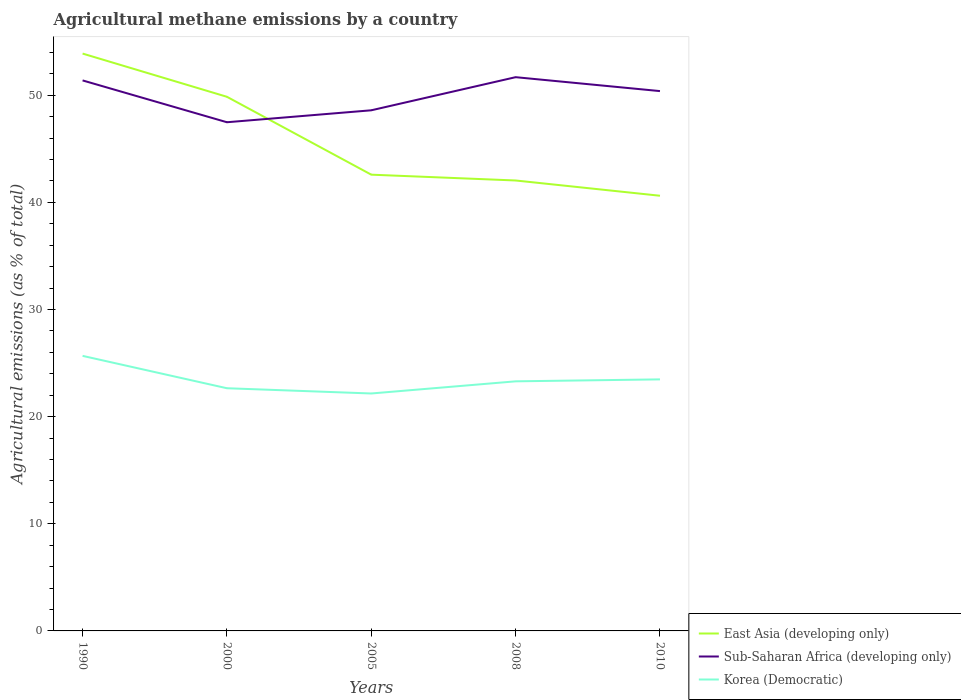How many different coloured lines are there?
Provide a short and direct response. 3. Is the number of lines equal to the number of legend labels?
Keep it short and to the point. Yes. Across all years, what is the maximum amount of agricultural methane emitted in East Asia (developing only)?
Your answer should be compact. 40.62. In which year was the amount of agricultural methane emitted in Sub-Saharan Africa (developing only) maximum?
Give a very brief answer. 2000. What is the total amount of agricultural methane emitted in Korea (Democratic) in the graph?
Your response must be concise. 2.19. What is the difference between the highest and the second highest amount of agricultural methane emitted in Korea (Democratic)?
Provide a succinct answer. 3.51. What is the difference between the highest and the lowest amount of agricultural methane emitted in Korea (Democratic)?
Keep it short and to the point. 2. Is the amount of agricultural methane emitted in Sub-Saharan Africa (developing only) strictly greater than the amount of agricultural methane emitted in East Asia (developing only) over the years?
Give a very brief answer. No. How many years are there in the graph?
Provide a short and direct response. 5. Does the graph contain any zero values?
Your response must be concise. No. Does the graph contain grids?
Offer a very short reply. No. How many legend labels are there?
Your response must be concise. 3. What is the title of the graph?
Your response must be concise. Agricultural methane emissions by a country. Does "Tunisia" appear as one of the legend labels in the graph?
Provide a succinct answer. No. What is the label or title of the X-axis?
Your answer should be very brief. Years. What is the label or title of the Y-axis?
Offer a terse response. Agricultural emissions (as % of total). What is the Agricultural emissions (as % of total) in East Asia (developing only) in 1990?
Provide a succinct answer. 53.89. What is the Agricultural emissions (as % of total) in Sub-Saharan Africa (developing only) in 1990?
Your answer should be compact. 51.39. What is the Agricultural emissions (as % of total) in Korea (Democratic) in 1990?
Keep it short and to the point. 25.68. What is the Agricultural emissions (as % of total) of East Asia (developing only) in 2000?
Provide a succinct answer. 49.86. What is the Agricultural emissions (as % of total) of Sub-Saharan Africa (developing only) in 2000?
Provide a short and direct response. 47.48. What is the Agricultural emissions (as % of total) in Korea (Democratic) in 2000?
Your response must be concise. 22.65. What is the Agricultural emissions (as % of total) of East Asia (developing only) in 2005?
Provide a succinct answer. 42.59. What is the Agricultural emissions (as % of total) of Sub-Saharan Africa (developing only) in 2005?
Give a very brief answer. 48.6. What is the Agricultural emissions (as % of total) of Korea (Democratic) in 2005?
Provide a short and direct response. 22.16. What is the Agricultural emissions (as % of total) of East Asia (developing only) in 2008?
Provide a short and direct response. 42.05. What is the Agricultural emissions (as % of total) of Sub-Saharan Africa (developing only) in 2008?
Ensure brevity in your answer.  51.69. What is the Agricultural emissions (as % of total) in Korea (Democratic) in 2008?
Give a very brief answer. 23.3. What is the Agricultural emissions (as % of total) in East Asia (developing only) in 2010?
Offer a terse response. 40.62. What is the Agricultural emissions (as % of total) in Sub-Saharan Africa (developing only) in 2010?
Offer a terse response. 50.39. What is the Agricultural emissions (as % of total) in Korea (Democratic) in 2010?
Ensure brevity in your answer.  23.48. Across all years, what is the maximum Agricultural emissions (as % of total) in East Asia (developing only)?
Your answer should be very brief. 53.89. Across all years, what is the maximum Agricultural emissions (as % of total) of Sub-Saharan Africa (developing only)?
Provide a succinct answer. 51.69. Across all years, what is the maximum Agricultural emissions (as % of total) of Korea (Democratic)?
Your answer should be very brief. 25.68. Across all years, what is the minimum Agricultural emissions (as % of total) of East Asia (developing only)?
Ensure brevity in your answer.  40.62. Across all years, what is the minimum Agricultural emissions (as % of total) of Sub-Saharan Africa (developing only)?
Your answer should be very brief. 47.48. Across all years, what is the minimum Agricultural emissions (as % of total) of Korea (Democratic)?
Provide a succinct answer. 22.16. What is the total Agricultural emissions (as % of total) of East Asia (developing only) in the graph?
Provide a short and direct response. 229.01. What is the total Agricultural emissions (as % of total) of Sub-Saharan Africa (developing only) in the graph?
Offer a very short reply. 249.55. What is the total Agricultural emissions (as % of total) of Korea (Democratic) in the graph?
Your answer should be compact. 117.27. What is the difference between the Agricultural emissions (as % of total) of East Asia (developing only) in 1990 and that in 2000?
Give a very brief answer. 4.03. What is the difference between the Agricultural emissions (as % of total) in Sub-Saharan Africa (developing only) in 1990 and that in 2000?
Make the answer very short. 3.9. What is the difference between the Agricultural emissions (as % of total) of Korea (Democratic) in 1990 and that in 2000?
Give a very brief answer. 3.02. What is the difference between the Agricultural emissions (as % of total) of East Asia (developing only) in 1990 and that in 2005?
Offer a very short reply. 11.3. What is the difference between the Agricultural emissions (as % of total) of Sub-Saharan Africa (developing only) in 1990 and that in 2005?
Your answer should be very brief. 2.79. What is the difference between the Agricultural emissions (as % of total) in Korea (Democratic) in 1990 and that in 2005?
Make the answer very short. 3.51. What is the difference between the Agricultural emissions (as % of total) of East Asia (developing only) in 1990 and that in 2008?
Your answer should be compact. 11.85. What is the difference between the Agricultural emissions (as % of total) in Sub-Saharan Africa (developing only) in 1990 and that in 2008?
Provide a short and direct response. -0.3. What is the difference between the Agricultural emissions (as % of total) in Korea (Democratic) in 1990 and that in 2008?
Provide a succinct answer. 2.38. What is the difference between the Agricultural emissions (as % of total) of East Asia (developing only) in 1990 and that in 2010?
Give a very brief answer. 13.27. What is the difference between the Agricultural emissions (as % of total) of Korea (Democratic) in 1990 and that in 2010?
Give a very brief answer. 2.19. What is the difference between the Agricultural emissions (as % of total) in East Asia (developing only) in 2000 and that in 2005?
Provide a short and direct response. 7.27. What is the difference between the Agricultural emissions (as % of total) in Sub-Saharan Africa (developing only) in 2000 and that in 2005?
Your answer should be very brief. -1.12. What is the difference between the Agricultural emissions (as % of total) of Korea (Democratic) in 2000 and that in 2005?
Give a very brief answer. 0.49. What is the difference between the Agricultural emissions (as % of total) in East Asia (developing only) in 2000 and that in 2008?
Provide a succinct answer. 7.81. What is the difference between the Agricultural emissions (as % of total) in Sub-Saharan Africa (developing only) in 2000 and that in 2008?
Make the answer very short. -4.21. What is the difference between the Agricultural emissions (as % of total) of Korea (Democratic) in 2000 and that in 2008?
Provide a succinct answer. -0.64. What is the difference between the Agricultural emissions (as % of total) in East Asia (developing only) in 2000 and that in 2010?
Your answer should be compact. 9.24. What is the difference between the Agricultural emissions (as % of total) in Sub-Saharan Africa (developing only) in 2000 and that in 2010?
Offer a very short reply. -2.91. What is the difference between the Agricultural emissions (as % of total) in Korea (Democratic) in 2000 and that in 2010?
Provide a short and direct response. -0.83. What is the difference between the Agricultural emissions (as % of total) of East Asia (developing only) in 2005 and that in 2008?
Offer a terse response. 0.54. What is the difference between the Agricultural emissions (as % of total) of Sub-Saharan Africa (developing only) in 2005 and that in 2008?
Offer a terse response. -3.09. What is the difference between the Agricultural emissions (as % of total) of Korea (Democratic) in 2005 and that in 2008?
Your answer should be very brief. -1.13. What is the difference between the Agricultural emissions (as % of total) of East Asia (developing only) in 2005 and that in 2010?
Your answer should be very brief. 1.97. What is the difference between the Agricultural emissions (as % of total) in Sub-Saharan Africa (developing only) in 2005 and that in 2010?
Offer a very short reply. -1.79. What is the difference between the Agricultural emissions (as % of total) in Korea (Democratic) in 2005 and that in 2010?
Make the answer very short. -1.32. What is the difference between the Agricultural emissions (as % of total) in East Asia (developing only) in 2008 and that in 2010?
Make the answer very short. 1.42. What is the difference between the Agricultural emissions (as % of total) of Sub-Saharan Africa (developing only) in 2008 and that in 2010?
Your answer should be very brief. 1.3. What is the difference between the Agricultural emissions (as % of total) in Korea (Democratic) in 2008 and that in 2010?
Offer a very short reply. -0.18. What is the difference between the Agricultural emissions (as % of total) in East Asia (developing only) in 1990 and the Agricultural emissions (as % of total) in Sub-Saharan Africa (developing only) in 2000?
Provide a short and direct response. 6.41. What is the difference between the Agricultural emissions (as % of total) of East Asia (developing only) in 1990 and the Agricultural emissions (as % of total) of Korea (Democratic) in 2000?
Your answer should be very brief. 31.24. What is the difference between the Agricultural emissions (as % of total) of Sub-Saharan Africa (developing only) in 1990 and the Agricultural emissions (as % of total) of Korea (Democratic) in 2000?
Your answer should be very brief. 28.73. What is the difference between the Agricultural emissions (as % of total) in East Asia (developing only) in 1990 and the Agricultural emissions (as % of total) in Sub-Saharan Africa (developing only) in 2005?
Keep it short and to the point. 5.29. What is the difference between the Agricultural emissions (as % of total) of East Asia (developing only) in 1990 and the Agricultural emissions (as % of total) of Korea (Democratic) in 2005?
Your response must be concise. 31.73. What is the difference between the Agricultural emissions (as % of total) of Sub-Saharan Africa (developing only) in 1990 and the Agricultural emissions (as % of total) of Korea (Democratic) in 2005?
Provide a short and direct response. 29.22. What is the difference between the Agricultural emissions (as % of total) of East Asia (developing only) in 1990 and the Agricultural emissions (as % of total) of Sub-Saharan Africa (developing only) in 2008?
Your response must be concise. 2.2. What is the difference between the Agricultural emissions (as % of total) of East Asia (developing only) in 1990 and the Agricultural emissions (as % of total) of Korea (Democratic) in 2008?
Keep it short and to the point. 30.6. What is the difference between the Agricultural emissions (as % of total) of Sub-Saharan Africa (developing only) in 1990 and the Agricultural emissions (as % of total) of Korea (Democratic) in 2008?
Ensure brevity in your answer.  28.09. What is the difference between the Agricultural emissions (as % of total) of East Asia (developing only) in 1990 and the Agricultural emissions (as % of total) of Sub-Saharan Africa (developing only) in 2010?
Provide a short and direct response. 3.5. What is the difference between the Agricultural emissions (as % of total) in East Asia (developing only) in 1990 and the Agricultural emissions (as % of total) in Korea (Democratic) in 2010?
Make the answer very short. 30.41. What is the difference between the Agricultural emissions (as % of total) of Sub-Saharan Africa (developing only) in 1990 and the Agricultural emissions (as % of total) of Korea (Democratic) in 2010?
Keep it short and to the point. 27.91. What is the difference between the Agricultural emissions (as % of total) in East Asia (developing only) in 2000 and the Agricultural emissions (as % of total) in Sub-Saharan Africa (developing only) in 2005?
Your answer should be very brief. 1.26. What is the difference between the Agricultural emissions (as % of total) in East Asia (developing only) in 2000 and the Agricultural emissions (as % of total) in Korea (Democratic) in 2005?
Your answer should be compact. 27.7. What is the difference between the Agricultural emissions (as % of total) in Sub-Saharan Africa (developing only) in 2000 and the Agricultural emissions (as % of total) in Korea (Democratic) in 2005?
Offer a terse response. 25.32. What is the difference between the Agricultural emissions (as % of total) of East Asia (developing only) in 2000 and the Agricultural emissions (as % of total) of Sub-Saharan Africa (developing only) in 2008?
Offer a terse response. -1.83. What is the difference between the Agricultural emissions (as % of total) of East Asia (developing only) in 2000 and the Agricultural emissions (as % of total) of Korea (Democratic) in 2008?
Provide a succinct answer. 26.56. What is the difference between the Agricultural emissions (as % of total) of Sub-Saharan Africa (developing only) in 2000 and the Agricultural emissions (as % of total) of Korea (Democratic) in 2008?
Offer a very short reply. 24.19. What is the difference between the Agricultural emissions (as % of total) in East Asia (developing only) in 2000 and the Agricultural emissions (as % of total) in Sub-Saharan Africa (developing only) in 2010?
Your answer should be very brief. -0.53. What is the difference between the Agricultural emissions (as % of total) in East Asia (developing only) in 2000 and the Agricultural emissions (as % of total) in Korea (Democratic) in 2010?
Provide a short and direct response. 26.38. What is the difference between the Agricultural emissions (as % of total) in Sub-Saharan Africa (developing only) in 2000 and the Agricultural emissions (as % of total) in Korea (Democratic) in 2010?
Provide a succinct answer. 24. What is the difference between the Agricultural emissions (as % of total) in East Asia (developing only) in 2005 and the Agricultural emissions (as % of total) in Sub-Saharan Africa (developing only) in 2008?
Your answer should be very brief. -9.1. What is the difference between the Agricultural emissions (as % of total) in East Asia (developing only) in 2005 and the Agricultural emissions (as % of total) in Korea (Democratic) in 2008?
Keep it short and to the point. 19.29. What is the difference between the Agricultural emissions (as % of total) in Sub-Saharan Africa (developing only) in 2005 and the Agricultural emissions (as % of total) in Korea (Democratic) in 2008?
Keep it short and to the point. 25.3. What is the difference between the Agricultural emissions (as % of total) of East Asia (developing only) in 2005 and the Agricultural emissions (as % of total) of Sub-Saharan Africa (developing only) in 2010?
Provide a succinct answer. -7.8. What is the difference between the Agricultural emissions (as % of total) of East Asia (developing only) in 2005 and the Agricultural emissions (as % of total) of Korea (Democratic) in 2010?
Provide a short and direct response. 19.11. What is the difference between the Agricultural emissions (as % of total) in Sub-Saharan Africa (developing only) in 2005 and the Agricultural emissions (as % of total) in Korea (Democratic) in 2010?
Your answer should be very brief. 25.12. What is the difference between the Agricultural emissions (as % of total) of East Asia (developing only) in 2008 and the Agricultural emissions (as % of total) of Sub-Saharan Africa (developing only) in 2010?
Offer a terse response. -8.34. What is the difference between the Agricultural emissions (as % of total) of East Asia (developing only) in 2008 and the Agricultural emissions (as % of total) of Korea (Democratic) in 2010?
Make the answer very short. 18.57. What is the difference between the Agricultural emissions (as % of total) of Sub-Saharan Africa (developing only) in 2008 and the Agricultural emissions (as % of total) of Korea (Democratic) in 2010?
Your answer should be very brief. 28.21. What is the average Agricultural emissions (as % of total) of East Asia (developing only) per year?
Provide a succinct answer. 45.8. What is the average Agricultural emissions (as % of total) of Sub-Saharan Africa (developing only) per year?
Keep it short and to the point. 49.91. What is the average Agricultural emissions (as % of total) of Korea (Democratic) per year?
Keep it short and to the point. 23.45. In the year 1990, what is the difference between the Agricultural emissions (as % of total) of East Asia (developing only) and Agricultural emissions (as % of total) of Sub-Saharan Africa (developing only)?
Provide a succinct answer. 2.51. In the year 1990, what is the difference between the Agricultural emissions (as % of total) in East Asia (developing only) and Agricultural emissions (as % of total) in Korea (Democratic)?
Offer a very short reply. 28.22. In the year 1990, what is the difference between the Agricultural emissions (as % of total) of Sub-Saharan Africa (developing only) and Agricultural emissions (as % of total) of Korea (Democratic)?
Your answer should be compact. 25.71. In the year 2000, what is the difference between the Agricultural emissions (as % of total) in East Asia (developing only) and Agricultural emissions (as % of total) in Sub-Saharan Africa (developing only)?
Give a very brief answer. 2.38. In the year 2000, what is the difference between the Agricultural emissions (as % of total) in East Asia (developing only) and Agricultural emissions (as % of total) in Korea (Democratic)?
Your answer should be very brief. 27.21. In the year 2000, what is the difference between the Agricultural emissions (as % of total) of Sub-Saharan Africa (developing only) and Agricultural emissions (as % of total) of Korea (Democratic)?
Your answer should be very brief. 24.83. In the year 2005, what is the difference between the Agricultural emissions (as % of total) in East Asia (developing only) and Agricultural emissions (as % of total) in Sub-Saharan Africa (developing only)?
Give a very brief answer. -6.01. In the year 2005, what is the difference between the Agricultural emissions (as % of total) of East Asia (developing only) and Agricultural emissions (as % of total) of Korea (Democratic)?
Give a very brief answer. 20.43. In the year 2005, what is the difference between the Agricultural emissions (as % of total) of Sub-Saharan Africa (developing only) and Agricultural emissions (as % of total) of Korea (Democratic)?
Offer a terse response. 26.43. In the year 2008, what is the difference between the Agricultural emissions (as % of total) in East Asia (developing only) and Agricultural emissions (as % of total) in Sub-Saharan Africa (developing only)?
Give a very brief answer. -9.64. In the year 2008, what is the difference between the Agricultural emissions (as % of total) of East Asia (developing only) and Agricultural emissions (as % of total) of Korea (Democratic)?
Your answer should be very brief. 18.75. In the year 2008, what is the difference between the Agricultural emissions (as % of total) in Sub-Saharan Africa (developing only) and Agricultural emissions (as % of total) in Korea (Democratic)?
Offer a very short reply. 28.39. In the year 2010, what is the difference between the Agricultural emissions (as % of total) in East Asia (developing only) and Agricultural emissions (as % of total) in Sub-Saharan Africa (developing only)?
Give a very brief answer. -9.77. In the year 2010, what is the difference between the Agricultural emissions (as % of total) of East Asia (developing only) and Agricultural emissions (as % of total) of Korea (Democratic)?
Offer a terse response. 17.14. In the year 2010, what is the difference between the Agricultural emissions (as % of total) in Sub-Saharan Africa (developing only) and Agricultural emissions (as % of total) in Korea (Democratic)?
Make the answer very short. 26.91. What is the ratio of the Agricultural emissions (as % of total) in East Asia (developing only) in 1990 to that in 2000?
Make the answer very short. 1.08. What is the ratio of the Agricultural emissions (as % of total) in Sub-Saharan Africa (developing only) in 1990 to that in 2000?
Offer a terse response. 1.08. What is the ratio of the Agricultural emissions (as % of total) in Korea (Democratic) in 1990 to that in 2000?
Your answer should be very brief. 1.13. What is the ratio of the Agricultural emissions (as % of total) of East Asia (developing only) in 1990 to that in 2005?
Provide a succinct answer. 1.27. What is the ratio of the Agricultural emissions (as % of total) in Sub-Saharan Africa (developing only) in 1990 to that in 2005?
Make the answer very short. 1.06. What is the ratio of the Agricultural emissions (as % of total) of Korea (Democratic) in 1990 to that in 2005?
Provide a succinct answer. 1.16. What is the ratio of the Agricultural emissions (as % of total) of East Asia (developing only) in 1990 to that in 2008?
Your response must be concise. 1.28. What is the ratio of the Agricultural emissions (as % of total) in Korea (Democratic) in 1990 to that in 2008?
Your answer should be very brief. 1.1. What is the ratio of the Agricultural emissions (as % of total) in East Asia (developing only) in 1990 to that in 2010?
Make the answer very short. 1.33. What is the ratio of the Agricultural emissions (as % of total) in Sub-Saharan Africa (developing only) in 1990 to that in 2010?
Your answer should be very brief. 1.02. What is the ratio of the Agricultural emissions (as % of total) of Korea (Democratic) in 1990 to that in 2010?
Your response must be concise. 1.09. What is the ratio of the Agricultural emissions (as % of total) in East Asia (developing only) in 2000 to that in 2005?
Your answer should be very brief. 1.17. What is the ratio of the Agricultural emissions (as % of total) of Sub-Saharan Africa (developing only) in 2000 to that in 2005?
Make the answer very short. 0.98. What is the ratio of the Agricultural emissions (as % of total) of Korea (Democratic) in 2000 to that in 2005?
Your answer should be very brief. 1.02. What is the ratio of the Agricultural emissions (as % of total) of East Asia (developing only) in 2000 to that in 2008?
Keep it short and to the point. 1.19. What is the ratio of the Agricultural emissions (as % of total) in Sub-Saharan Africa (developing only) in 2000 to that in 2008?
Make the answer very short. 0.92. What is the ratio of the Agricultural emissions (as % of total) of Korea (Democratic) in 2000 to that in 2008?
Your answer should be compact. 0.97. What is the ratio of the Agricultural emissions (as % of total) in East Asia (developing only) in 2000 to that in 2010?
Give a very brief answer. 1.23. What is the ratio of the Agricultural emissions (as % of total) in Sub-Saharan Africa (developing only) in 2000 to that in 2010?
Make the answer very short. 0.94. What is the ratio of the Agricultural emissions (as % of total) in Korea (Democratic) in 2000 to that in 2010?
Your answer should be compact. 0.96. What is the ratio of the Agricultural emissions (as % of total) in East Asia (developing only) in 2005 to that in 2008?
Ensure brevity in your answer.  1.01. What is the ratio of the Agricultural emissions (as % of total) in Sub-Saharan Africa (developing only) in 2005 to that in 2008?
Your answer should be compact. 0.94. What is the ratio of the Agricultural emissions (as % of total) of Korea (Democratic) in 2005 to that in 2008?
Give a very brief answer. 0.95. What is the ratio of the Agricultural emissions (as % of total) of East Asia (developing only) in 2005 to that in 2010?
Ensure brevity in your answer.  1.05. What is the ratio of the Agricultural emissions (as % of total) of Sub-Saharan Africa (developing only) in 2005 to that in 2010?
Provide a succinct answer. 0.96. What is the ratio of the Agricultural emissions (as % of total) in Korea (Democratic) in 2005 to that in 2010?
Offer a very short reply. 0.94. What is the ratio of the Agricultural emissions (as % of total) in East Asia (developing only) in 2008 to that in 2010?
Keep it short and to the point. 1.04. What is the ratio of the Agricultural emissions (as % of total) in Sub-Saharan Africa (developing only) in 2008 to that in 2010?
Make the answer very short. 1.03. What is the difference between the highest and the second highest Agricultural emissions (as % of total) of East Asia (developing only)?
Give a very brief answer. 4.03. What is the difference between the highest and the second highest Agricultural emissions (as % of total) of Sub-Saharan Africa (developing only)?
Provide a succinct answer. 0.3. What is the difference between the highest and the second highest Agricultural emissions (as % of total) in Korea (Democratic)?
Your answer should be compact. 2.19. What is the difference between the highest and the lowest Agricultural emissions (as % of total) of East Asia (developing only)?
Provide a succinct answer. 13.27. What is the difference between the highest and the lowest Agricultural emissions (as % of total) of Sub-Saharan Africa (developing only)?
Give a very brief answer. 4.21. What is the difference between the highest and the lowest Agricultural emissions (as % of total) in Korea (Democratic)?
Make the answer very short. 3.51. 